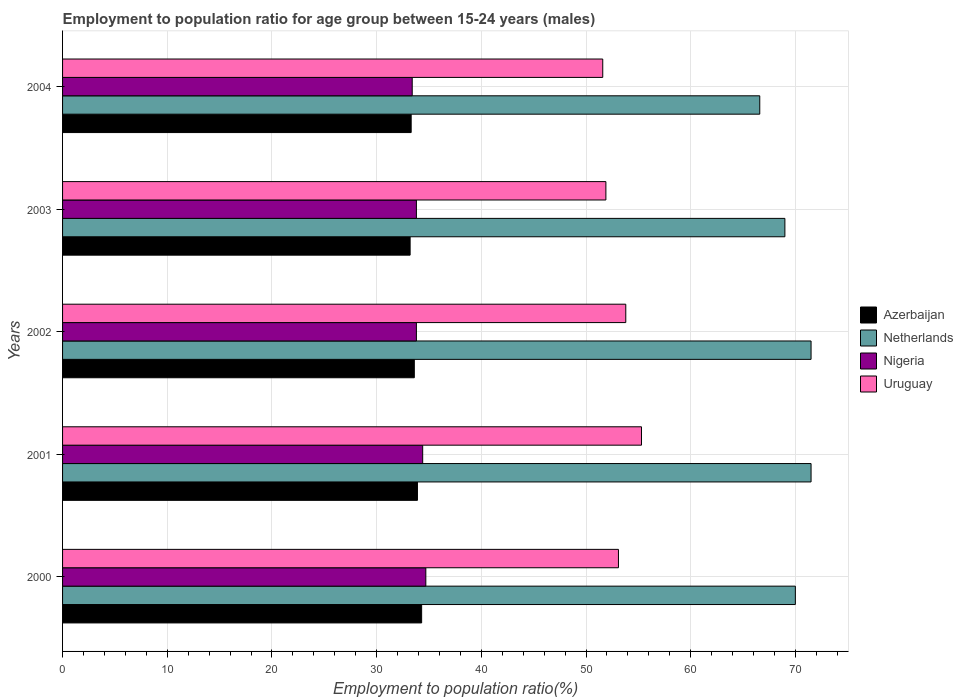How many different coloured bars are there?
Ensure brevity in your answer.  4. How many groups of bars are there?
Provide a short and direct response. 5. Are the number of bars per tick equal to the number of legend labels?
Offer a terse response. Yes. Are the number of bars on each tick of the Y-axis equal?
Keep it short and to the point. Yes. How many bars are there on the 5th tick from the top?
Give a very brief answer. 4. How many bars are there on the 3rd tick from the bottom?
Your answer should be very brief. 4. What is the label of the 4th group of bars from the top?
Give a very brief answer. 2001. In how many cases, is the number of bars for a given year not equal to the number of legend labels?
Your answer should be compact. 0. What is the employment to population ratio in Uruguay in 2004?
Provide a short and direct response. 51.6. Across all years, what is the maximum employment to population ratio in Azerbaijan?
Your response must be concise. 34.3. Across all years, what is the minimum employment to population ratio in Azerbaijan?
Offer a very short reply. 33.2. In which year was the employment to population ratio in Netherlands minimum?
Ensure brevity in your answer.  2004. What is the total employment to population ratio in Nigeria in the graph?
Offer a very short reply. 170.1. What is the difference between the employment to population ratio in Nigeria in 2000 and that in 2002?
Ensure brevity in your answer.  0.9. What is the difference between the employment to population ratio in Uruguay in 2004 and the employment to population ratio in Nigeria in 2000?
Provide a short and direct response. 16.9. What is the average employment to population ratio in Azerbaijan per year?
Your answer should be very brief. 33.66. In the year 2001, what is the difference between the employment to population ratio in Azerbaijan and employment to population ratio in Uruguay?
Keep it short and to the point. -21.4. In how many years, is the employment to population ratio in Netherlands greater than 66 %?
Give a very brief answer. 5. What is the ratio of the employment to population ratio in Nigeria in 2000 to that in 2004?
Offer a very short reply. 1.04. Is the employment to population ratio in Netherlands in 2002 less than that in 2003?
Provide a short and direct response. No. What is the difference between the highest and the second highest employment to population ratio in Netherlands?
Provide a succinct answer. 0. What is the difference between the highest and the lowest employment to population ratio in Nigeria?
Make the answer very short. 1.3. In how many years, is the employment to population ratio in Netherlands greater than the average employment to population ratio in Netherlands taken over all years?
Offer a very short reply. 3. Is it the case that in every year, the sum of the employment to population ratio in Netherlands and employment to population ratio in Uruguay is greater than the sum of employment to population ratio in Azerbaijan and employment to population ratio in Nigeria?
Your response must be concise. Yes. What does the 2nd bar from the top in 2002 represents?
Make the answer very short. Nigeria. What does the 1st bar from the bottom in 2001 represents?
Your response must be concise. Azerbaijan. Is it the case that in every year, the sum of the employment to population ratio in Azerbaijan and employment to population ratio in Nigeria is greater than the employment to population ratio in Netherlands?
Provide a succinct answer. No. Are all the bars in the graph horizontal?
Provide a short and direct response. Yes. How many years are there in the graph?
Your answer should be very brief. 5. What is the difference between two consecutive major ticks on the X-axis?
Give a very brief answer. 10. What is the title of the graph?
Make the answer very short. Employment to population ratio for age group between 15-24 years (males). What is the label or title of the Y-axis?
Offer a terse response. Years. What is the Employment to population ratio(%) of Azerbaijan in 2000?
Make the answer very short. 34.3. What is the Employment to population ratio(%) in Netherlands in 2000?
Offer a terse response. 70. What is the Employment to population ratio(%) of Nigeria in 2000?
Your response must be concise. 34.7. What is the Employment to population ratio(%) in Uruguay in 2000?
Offer a very short reply. 53.1. What is the Employment to population ratio(%) of Azerbaijan in 2001?
Your response must be concise. 33.9. What is the Employment to population ratio(%) of Netherlands in 2001?
Your answer should be compact. 71.5. What is the Employment to population ratio(%) in Nigeria in 2001?
Keep it short and to the point. 34.4. What is the Employment to population ratio(%) in Uruguay in 2001?
Provide a short and direct response. 55.3. What is the Employment to population ratio(%) in Azerbaijan in 2002?
Provide a short and direct response. 33.6. What is the Employment to population ratio(%) of Netherlands in 2002?
Give a very brief answer. 71.5. What is the Employment to population ratio(%) of Nigeria in 2002?
Make the answer very short. 33.8. What is the Employment to population ratio(%) in Uruguay in 2002?
Give a very brief answer. 53.8. What is the Employment to population ratio(%) in Azerbaijan in 2003?
Offer a terse response. 33.2. What is the Employment to population ratio(%) of Nigeria in 2003?
Ensure brevity in your answer.  33.8. What is the Employment to population ratio(%) in Uruguay in 2003?
Keep it short and to the point. 51.9. What is the Employment to population ratio(%) in Azerbaijan in 2004?
Keep it short and to the point. 33.3. What is the Employment to population ratio(%) in Netherlands in 2004?
Provide a succinct answer. 66.6. What is the Employment to population ratio(%) of Nigeria in 2004?
Give a very brief answer. 33.4. What is the Employment to population ratio(%) of Uruguay in 2004?
Offer a terse response. 51.6. Across all years, what is the maximum Employment to population ratio(%) of Azerbaijan?
Provide a short and direct response. 34.3. Across all years, what is the maximum Employment to population ratio(%) in Netherlands?
Offer a very short reply. 71.5. Across all years, what is the maximum Employment to population ratio(%) of Nigeria?
Ensure brevity in your answer.  34.7. Across all years, what is the maximum Employment to population ratio(%) in Uruguay?
Provide a short and direct response. 55.3. Across all years, what is the minimum Employment to population ratio(%) in Azerbaijan?
Your response must be concise. 33.2. Across all years, what is the minimum Employment to population ratio(%) of Netherlands?
Offer a terse response. 66.6. Across all years, what is the minimum Employment to population ratio(%) in Nigeria?
Your answer should be very brief. 33.4. Across all years, what is the minimum Employment to population ratio(%) in Uruguay?
Provide a short and direct response. 51.6. What is the total Employment to population ratio(%) in Azerbaijan in the graph?
Offer a very short reply. 168.3. What is the total Employment to population ratio(%) of Netherlands in the graph?
Make the answer very short. 348.6. What is the total Employment to population ratio(%) of Nigeria in the graph?
Your answer should be compact. 170.1. What is the total Employment to population ratio(%) of Uruguay in the graph?
Make the answer very short. 265.7. What is the difference between the Employment to population ratio(%) in Azerbaijan in 2000 and that in 2001?
Offer a very short reply. 0.4. What is the difference between the Employment to population ratio(%) in Netherlands in 2000 and that in 2002?
Give a very brief answer. -1.5. What is the difference between the Employment to population ratio(%) in Nigeria in 2000 and that in 2002?
Give a very brief answer. 0.9. What is the difference between the Employment to population ratio(%) in Uruguay in 2000 and that in 2002?
Your answer should be very brief. -0.7. What is the difference between the Employment to population ratio(%) of Azerbaijan in 2000 and that in 2003?
Provide a succinct answer. 1.1. What is the difference between the Employment to population ratio(%) of Netherlands in 2000 and that in 2003?
Give a very brief answer. 1. What is the difference between the Employment to population ratio(%) in Nigeria in 2000 and that in 2003?
Your response must be concise. 0.9. What is the difference between the Employment to population ratio(%) of Azerbaijan in 2000 and that in 2004?
Your answer should be very brief. 1. What is the difference between the Employment to population ratio(%) in Netherlands in 2000 and that in 2004?
Give a very brief answer. 3.4. What is the difference between the Employment to population ratio(%) in Netherlands in 2001 and that in 2002?
Offer a terse response. 0. What is the difference between the Employment to population ratio(%) of Netherlands in 2001 and that in 2003?
Make the answer very short. 2.5. What is the difference between the Employment to population ratio(%) of Azerbaijan in 2001 and that in 2004?
Provide a short and direct response. 0.6. What is the difference between the Employment to population ratio(%) in Nigeria in 2001 and that in 2004?
Your answer should be compact. 1. What is the difference between the Employment to population ratio(%) of Netherlands in 2002 and that in 2003?
Provide a short and direct response. 2.5. What is the difference between the Employment to population ratio(%) in Uruguay in 2002 and that in 2003?
Your response must be concise. 1.9. What is the difference between the Employment to population ratio(%) in Azerbaijan in 2002 and that in 2004?
Ensure brevity in your answer.  0.3. What is the difference between the Employment to population ratio(%) of Netherlands in 2002 and that in 2004?
Your answer should be compact. 4.9. What is the difference between the Employment to population ratio(%) in Nigeria in 2003 and that in 2004?
Offer a very short reply. 0.4. What is the difference between the Employment to population ratio(%) of Uruguay in 2003 and that in 2004?
Make the answer very short. 0.3. What is the difference between the Employment to population ratio(%) of Azerbaijan in 2000 and the Employment to population ratio(%) of Netherlands in 2001?
Keep it short and to the point. -37.2. What is the difference between the Employment to population ratio(%) of Azerbaijan in 2000 and the Employment to population ratio(%) of Uruguay in 2001?
Provide a succinct answer. -21. What is the difference between the Employment to population ratio(%) in Netherlands in 2000 and the Employment to population ratio(%) in Nigeria in 2001?
Ensure brevity in your answer.  35.6. What is the difference between the Employment to population ratio(%) in Nigeria in 2000 and the Employment to population ratio(%) in Uruguay in 2001?
Offer a very short reply. -20.6. What is the difference between the Employment to population ratio(%) in Azerbaijan in 2000 and the Employment to population ratio(%) in Netherlands in 2002?
Offer a very short reply. -37.2. What is the difference between the Employment to population ratio(%) of Azerbaijan in 2000 and the Employment to population ratio(%) of Nigeria in 2002?
Offer a terse response. 0.5. What is the difference between the Employment to population ratio(%) in Azerbaijan in 2000 and the Employment to population ratio(%) in Uruguay in 2002?
Your answer should be very brief. -19.5. What is the difference between the Employment to population ratio(%) of Netherlands in 2000 and the Employment to population ratio(%) of Nigeria in 2002?
Your response must be concise. 36.2. What is the difference between the Employment to population ratio(%) of Netherlands in 2000 and the Employment to population ratio(%) of Uruguay in 2002?
Give a very brief answer. 16.2. What is the difference between the Employment to population ratio(%) of Nigeria in 2000 and the Employment to population ratio(%) of Uruguay in 2002?
Your answer should be very brief. -19.1. What is the difference between the Employment to population ratio(%) in Azerbaijan in 2000 and the Employment to population ratio(%) in Netherlands in 2003?
Provide a succinct answer. -34.7. What is the difference between the Employment to population ratio(%) in Azerbaijan in 2000 and the Employment to population ratio(%) in Uruguay in 2003?
Your response must be concise. -17.6. What is the difference between the Employment to population ratio(%) in Netherlands in 2000 and the Employment to population ratio(%) in Nigeria in 2003?
Your answer should be compact. 36.2. What is the difference between the Employment to population ratio(%) of Nigeria in 2000 and the Employment to population ratio(%) of Uruguay in 2003?
Your answer should be compact. -17.2. What is the difference between the Employment to population ratio(%) of Azerbaijan in 2000 and the Employment to population ratio(%) of Netherlands in 2004?
Your answer should be very brief. -32.3. What is the difference between the Employment to population ratio(%) in Azerbaijan in 2000 and the Employment to population ratio(%) in Nigeria in 2004?
Keep it short and to the point. 0.9. What is the difference between the Employment to population ratio(%) of Azerbaijan in 2000 and the Employment to population ratio(%) of Uruguay in 2004?
Your response must be concise. -17.3. What is the difference between the Employment to population ratio(%) of Netherlands in 2000 and the Employment to population ratio(%) of Nigeria in 2004?
Ensure brevity in your answer.  36.6. What is the difference between the Employment to population ratio(%) of Nigeria in 2000 and the Employment to population ratio(%) of Uruguay in 2004?
Offer a very short reply. -16.9. What is the difference between the Employment to population ratio(%) of Azerbaijan in 2001 and the Employment to population ratio(%) of Netherlands in 2002?
Offer a very short reply. -37.6. What is the difference between the Employment to population ratio(%) in Azerbaijan in 2001 and the Employment to population ratio(%) in Uruguay in 2002?
Your answer should be compact. -19.9. What is the difference between the Employment to population ratio(%) in Netherlands in 2001 and the Employment to population ratio(%) in Nigeria in 2002?
Keep it short and to the point. 37.7. What is the difference between the Employment to population ratio(%) in Netherlands in 2001 and the Employment to population ratio(%) in Uruguay in 2002?
Give a very brief answer. 17.7. What is the difference between the Employment to population ratio(%) in Nigeria in 2001 and the Employment to population ratio(%) in Uruguay in 2002?
Provide a succinct answer. -19.4. What is the difference between the Employment to population ratio(%) of Azerbaijan in 2001 and the Employment to population ratio(%) of Netherlands in 2003?
Ensure brevity in your answer.  -35.1. What is the difference between the Employment to population ratio(%) of Azerbaijan in 2001 and the Employment to population ratio(%) of Nigeria in 2003?
Offer a terse response. 0.1. What is the difference between the Employment to population ratio(%) of Netherlands in 2001 and the Employment to population ratio(%) of Nigeria in 2003?
Keep it short and to the point. 37.7. What is the difference between the Employment to population ratio(%) in Netherlands in 2001 and the Employment to population ratio(%) in Uruguay in 2003?
Make the answer very short. 19.6. What is the difference between the Employment to population ratio(%) in Nigeria in 2001 and the Employment to population ratio(%) in Uruguay in 2003?
Your response must be concise. -17.5. What is the difference between the Employment to population ratio(%) of Azerbaijan in 2001 and the Employment to population ratio(%) of Netherlands in 2004?
Your response must be concise. -32.7. What is the difference between the Employment to population ratio(%) in Azerbaijan in 2001 and the Employment to population ratio(%) in Uruguay in 2004?
Provide a short and direct response. -17.7. What is the difference between the Employment to population ratio(%) of Netherlands in 2001 and the Employment to population ratio(%) of Nigeria in 2004?
Keep it short and to the point. 38.1. What is the difference between the Employment to population ratio(%) of Nigeria in 2001 and the Employment to population ratio(%) of Uruguay in 2004?
Your answer should be compact. -17.2. What is the difference between the Employment to population ratio(%) in Azerbaijan in 2002 and the Employment to population ratio(%) in Netherlands in 2003?
Keep it short and to the point. -35.4. What is the difference between the Employment to population ratio(%) in Azerbaijan in 2002 and the Employment to population ratio(%) in Nigeria in 2003?
Provide a short and direct response. -0.2. What is the difference between the Employment to population ratio(%) in Azerbaijan in 2002 and the Employment to population ratio(%) in Uruguay in 2003?
Give a very brief answer. -18.3. What is the difference between the Employment to population ratio(%) in Netherlands in 2002 and the Employment to population ratio(%) in Nigeria in 2003?
Offer a very short reply. 37.7. What is the difference between the Employment to population ratio(%) of Netherlands in 2002 and the Employment to population ratio(%) of Uruguay in 2003?
Provide a short and direct response. 19.6. What is the difference between the Employment to population ratio(%) in Nigeria in 2002 and the Employment to population ratio(%) in Uruguay in 2003?
Ensure brevity in your answer.  -18.1. What is the difference between the Employment to population ratio(%) of Azerbaijan in 2002 and the Employment to population ratio(%) of Netherlands in 2004?
Your answer should be compact. -33. What is the difference between the Employment to population ratio(%) of Netherlands in 2002 and the Employment to population ratio(%) of Nigeria in 2004?
Offer a terse response. 38.1. What is the difference between the Employment to population ratio(%) in Netherlands in 2002 and the Employment to population ratio(%) in Uruguay in 2004?
Give a very brief answer. 19.9. What is the difference between the Employment to population ratio(%) in Nigeria in 2002 and the Employment to population ratio(%) in Uruguay in 2004?
Your answer should be compact. -17.8. What is the difference between the Employment to population ratio(%) of Azerbaijan in 2003 and the Employment to population ratio(%) of Netherlands in 2004?
Keep it short and to the point. -33.4. What is the difference between the Employment to population ratio(%) in Azerbaijan in 2003 and the Employment to population ratio(%) in Uruguay in 2004?
Offer a terse response. -18.4. What is the difference between the Employment to population ratio(%) in Netherlands in 2003 and the Employment to population ratio(%) in Nigeria in 2004?
Ensure brevity in your answer.  35.6. What is the difference between the Employment to population ratio(%) of Netherlands in 2003 and the Employment to population ratio(%) of Uruguay in 2004?
Your response must be concise. 17.4. What is the difference between the Employment to population ratio(%) in Nigeria in 2003 and the Employment to population ratio(%) in Uruguay in 2004?
Your answer should be very brief. -17.8. What is the average Employment to population ratio(%) in Azerbaijan per year?
Ensure brevity in your answer.  33.66. What is the average Employment to population ratio(%) in Netherlands per year?
Provide a short and direct response. 69.72. What is the average Employment to population ratio(%) of Nigeria per year?
Give a very brief answer. 34.02. What is the average Employment to population ratio(%) in Uruguay per year?
Your answer should be compact. 53.14. In the year 2000, what is the difference between the Employment to population ratio(%) in Azerbaijan and Employment to population ratio(%) in Netherlands?
Your answer should be very brief. -35.7. In the year 2000, what is the difference between the Employment to population ratio(%) in Azerbaijan and Employment to population ratio(%) in Uruguay?
Your response must be concise. -18.8. In the year 2000, what is the difference between the Employment to population ratio(%) in Netherlands and Employment to population ratio(%) in Nigeria?
Ensure brevity in your answer.  35.3. In the year 2000, what is the difference between the Employment to population ratio(%) in Netherlands and Employment to population ratio(%) in Uruguay?
Offer a very short reply. 16.9. In the year 2000, what is the difference between the Employment to population ratio(%) in Nigeria and Employment to population ratio(%) in Uruguay?
Offer a very short reply. -18.4. In the year 2001, what is the difference between the Employment to population ratio(%) of Azerbaijan and Employment to population ratio(%) of Netherlands?
Offer a terse response. -37.6. In the year 2001, what is the difference between the Employment to population ratio(%) in Azerbaijan and Employment to population ratio(%) in Uruguay?
Offer a very short reply. -21.4. In the year 2001, what is the difference between the Employment to population ratio(%) in Netherlands and Employment to population ratio(%) in Nigeria?
Offer a terse response. 37.1. In the year 2001, what is the difference between the Employment to population ratio(%) of Nigeria and Employment to population ratio(%) of Uruguay?
Offer a very short reply. -20.9. In the year 2002, what is the difference between the Employment to population ratio(%) of Azerbaijan and Employment to population ratio(%) of Netherlands?
Your answer should be compact. -37.9. In the year 2002, what is the difference between the Employment to population ratio(%) in Azerbaijan and Employment to population ratio(%) in Nigeria?
Your response must be concise. -0.2. In the year 2002, what is the difference between the Employment to population ratio(%) of Azerbaijan and Employment to population ratio(%) of Uruguay?
Ensure brevity in your answer.  -20.2. In the year 2002, what is the difference between the Employment to population ratio(%) of Netherlands and Employment to population ratio(%) of Nigeria?
Your answer should be compact. 37.7. In the year 2002, what is the difference between the Employment to population ratio(%) of Netherlands and Employment to population ratio(%) of Uruguay?
Give a very brief answer. 17.7. In the year 2003, what is the difference between the Employment to population ratio(%) in Azerbaijan and Employment to population ratio(%) in Netherlands?
Your answer should be very brief. -35.8. In the year 2003, what is the difference between the Employment to population ratio(%) in Azerbaijan and Employment to population ratio(%) in Uruguay?
Ensure brevity in your answer.  -18.7. In the year 2003, what is the difference between the Employment to population ratio(%) of Netherlands and Employment to population ratio(%) of Nigeria?
Provide a short and direct response. 35.2. In the year 2003, what is the difference between the Employment to population ratio(%) of Nigeria and Employment to population ratio(%) of Uruguay?
Offer a terse response. -18.1. In the year 2004, what is the difference between the Employment to population ratio(%) in Azerbaijan and Employment to population ratio(%) in Netherlands?
Your answer should be compact. -33.3. In the year 2004, what is the difference between the Employment to population ratio(%) of Azerbaijan and Employment to population ratio(%) of Uruguay?
Your answer should be compact. -18.3. In the year 2004, what is the difference between the Employment to population ratio(%) of Netherlands and Employment to population ratio(%) of Nigeria?
Your response must be concise. 33.2. In the year 2004, what is the difference between the Employment to population ratio(%) of Nigeria and Employment to population ratio(%) of Uruguay?
Offer a very short reply. -18.2. What is the ratio of the Employment to population ratio(%) in Azerbaijan in 2000 to that in 2001?
Your answer should be compact. 1.01. What is the ratio of the Employment to population ratio(%) in Netherlands in 2000 to that in 2001?
Offer a terse response. 0.98. What is the ratio of the Employment to population ratio(%) in Nigeria in 2000 to that in 2001?
Make the answer very short. 1.01. What is the ratio of the Employment to population ratio(%) of Uruguay in 2000 to that in 2001?
Your answer should be compact. 0.96. What is the ratio of the Employment to population ratio(%) of Azerbaijan in 2000 to that in 2002?
Provide a succinct answer. 1.02. What is the ratio of the Employment to population ratio(%) in Netherlands in 2000 to that in 2002?
Make the answer very short. 0.98. What is the ratio of the Employment to population ratio(%) in Nigeria in 2000 to that in 2002?
Provide a short and direct response. 1.03. What is the ratio of the Employment to population ratio(%) in Azerbaijan in 2000 to that in 2003?
Offer a terse response. 1.03. What is the ratio of the Employment to population ratio(%) in Netherlands in 2000 to that in 2003?
Provide a short and direct response. 1.01. What is the ratio of the Employment to population ratio(%) of Nigeria in 2000 to that in 2003?
Keep it short and to the point. 1.03. What is the ratio of the Employment to population ratio(%) of Uruguay in 2000 to that in 2003?
Offer a terse response. 1.02. What is the ratio of the Employment to population ratio(%) of Azerbaijan in 2000 to that in 2004?
Offer a very short reply. 1.03. What is the ratio of the Employment to population ratio(%) in Netherlands in 2000 to that in 2004?
Your answer should be very brief. 1.05. What is the ratio of the Employment to population ratio(%) in Nigeria in 2000 to that in 2004?
Your answer should be very brief. 1.04. What is the ratio of the Employment to population ratio(%) in Uruguay in 2000 to that in 2004?
Provide a short and direct response. 1.03. What is the ratio of the Employment to population ratio(%) of Azerbaijan in 2001 to that in 2002?
Your answer should be compact. 1.01. What is the ratio of the Employment to population ratio(%) of Netherlands in 2001 to that in 2002?
Offer a very short reply. 1. What is the ratio of the Employment to population ratio(%) of Nigeria in 2001 to that in 2002?
Make the answer very short. 1.02. What is the ratio of the Employment to population ratio(%) of Uruguay in 2001 to that in 2002?
Your answer should be very brief. 1.03. What is the ratio of the Employment to population ratio(%) of Azerbaijan in 2001 to that in 2003?
Make the answer very short. 1.02. What is the ratio of the Employment to population ratio(%) of Netherlands in 2001 to that in 2003?
Offer a very short reply. 1.04. What is the ratio of the Employment to population ratio(%) of Nigeria in 2001 to that in 2003?
Your answer should be very brief. 1.02. What is the ratio of the Employment to population ratio(%) of Uruguay in 2001 to that in 2003?
Your answer should be compact. 1.07. What is the ratio of the Employment to population ratio(%) in Azerbaijan in 2001 to that in 2004?
Offer a terse response. 1.02. What is the ratio of the Employment to population ratio(%) of Netherlands in 2001 to that in 2004?
Your answer should be compact. 1.07. What is the ratio of the Employment to population ratio(%) in Nigeria in 2001 to that in 2004?
Ensure brevity in your answer.  1.03. What is the ratio of the Employment to population ratio(%) in Uruguay in 2001 to that in 2004?
Your response must be concise. 1.07. What is the ratio of the Employment to population ratio(%) of Netherlands in 2002 to that in 2003?
Your response must be concise. 1.04. What is the ratio of the Employment to population ratio(%) of Nigeria in 2002 to that in 2003?
Keep it short and to the point. 1. What is the ratio of the Employment to population ratio(%) in Uruguay in 2002 to that in 2003?
Keep it short and to the point. 1.04. What is the ratio of the Employment to population ratio(%) of Netherlands in 2002 to that in 2004?
Keep it short and to the point. 1.07. What is the ratio of the Employment to population ratio(%) in Uruguay in 2002 to that in 2004?
Your answer should be compact. 1.04. What is the ratio of the Employment to population ratio(%) of Azerbaijan in 2003 to that in 2004?
Provide a succinct answer. 1. What is the ratio of the Employment to population ratio(%) of Netherlands in 2003 to that in 2004?
Your answer should be compact. 1.04. What is the ratio of the Employment to population ratio(%) in Nigeria in 2003 to that in 2004?
Make the answer very short. 1.01. What is the ratio of the Employment to population ratio(%) in Uruguay in 2003 to that in 2004?
Your answer should be compact. 1.01. What is the difference between the highest and the second highest Employment to population ratio(%) in Azerbaijan?
Your answer should be compact. 0.4. What is the difference between the highest and the second highest Employment to population ratio(%) of Nigeria?
Your response must be concise. 0.3. What is the difference between the highest and the lowest Employment to population ratio(%) of Nigeria?
Provide a succinct answer. 1.3. What is the difference between the highest and the lowest Employment to population ratio(%) in Uruguay?
Make the answer very short. 3.7. 